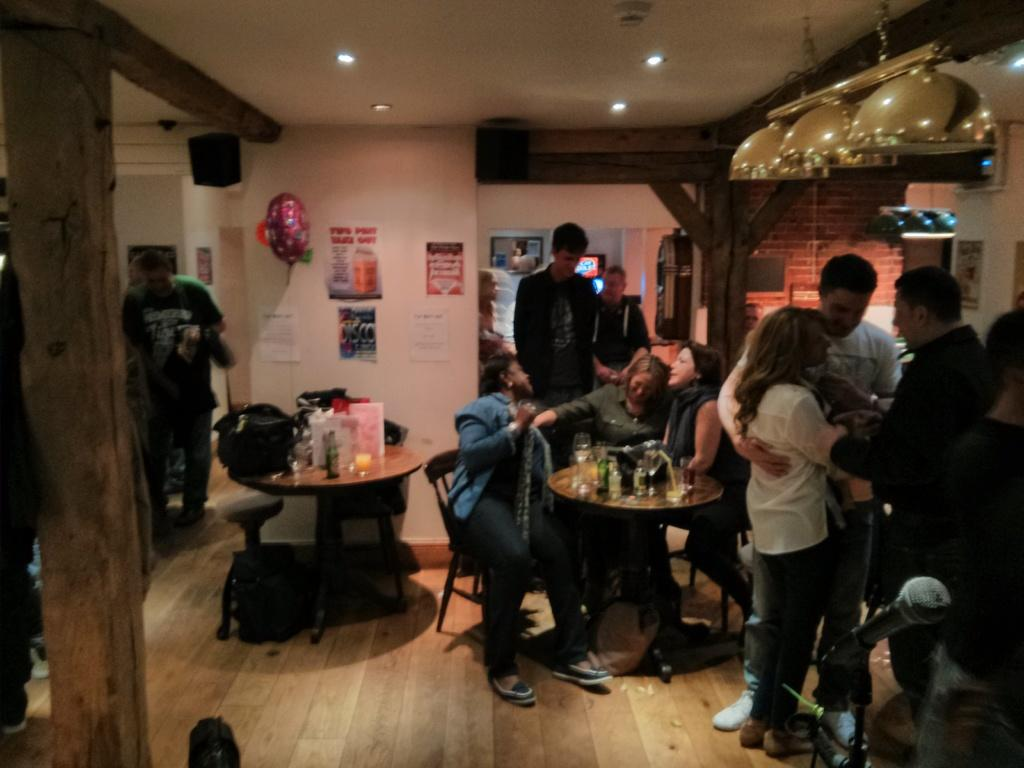What are the people in the image doing? There is a group of people sitting in chairs. What is in front of the sitting people? There is a table in front of the sitting people. Where are the standing people located in the image? There are people standing in the right corner of the image. What type of sofa can be seen in the image? There is no sofa present in the image. What industry is depicted in the image? The image does not depict any specific industry. 